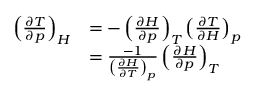<formula> <loc_0><loc_0><loc_500><loc_500>{ \begin{array} { r l } { \left ( { \frac { \partial T } { \partial p } } \right ) _ { H } } & { = - \left ( { \frac { \partial H } { \partial p } } \right ) _ { T } \left ( { \frac { \partial T } { \partial H } } \right ) _ { p } } \\ & { = { \frac { - 1 } { \left ( { \frac { \partial H } { \partial T } } \right ) _ { p } } } \left ( { \frac { \partial H } { \partial p } } \right ) _ { T } } \end{array} }</formula> 